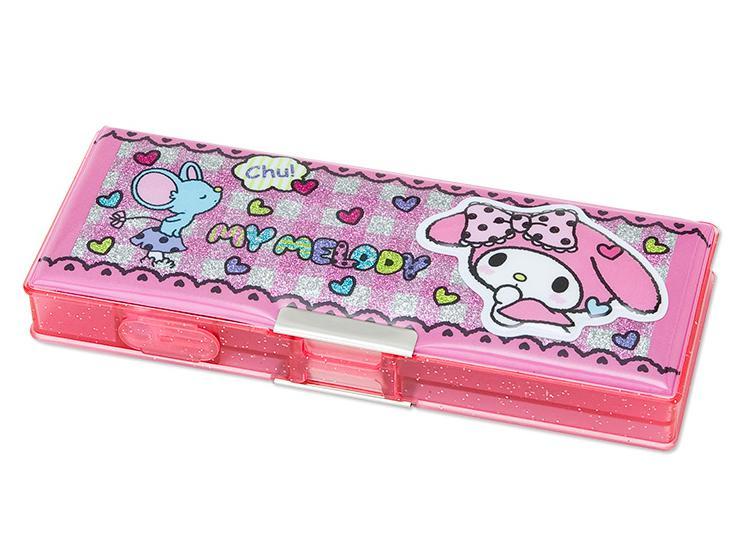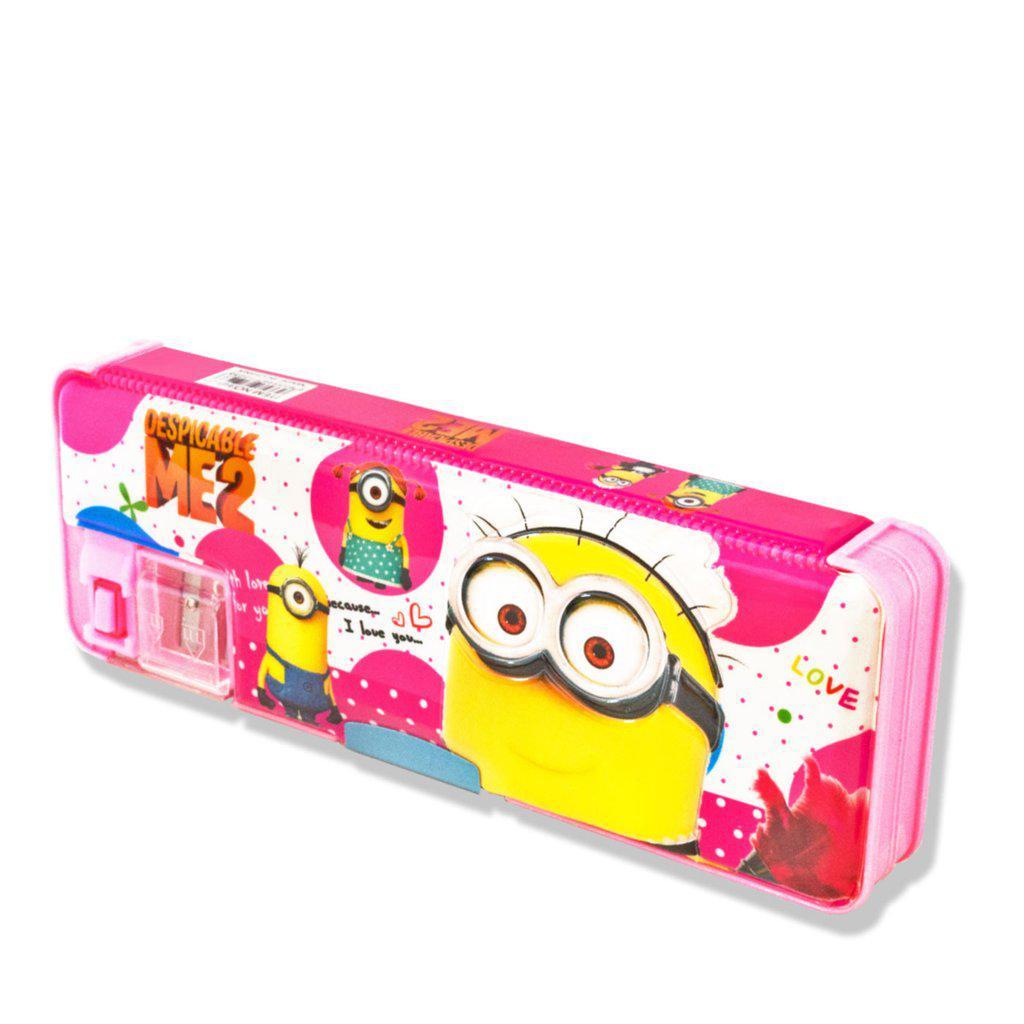The first image is the image on the left, the second image is the image on the right. Evaluate the accuracy of this statement regarding the images: "There are exactly two hard plastic pencil boxes that are both closed.". Is it true? Answer yes or no. Yes. The first image is the image on the left, the second image is the image on the right. Examine the images to the left and right. Is the description "Right image shows a pencil case decorated on top with a variety of cute animals, including a rabbit, dog, cat and bear." accurate? Answer yes or no. No. 